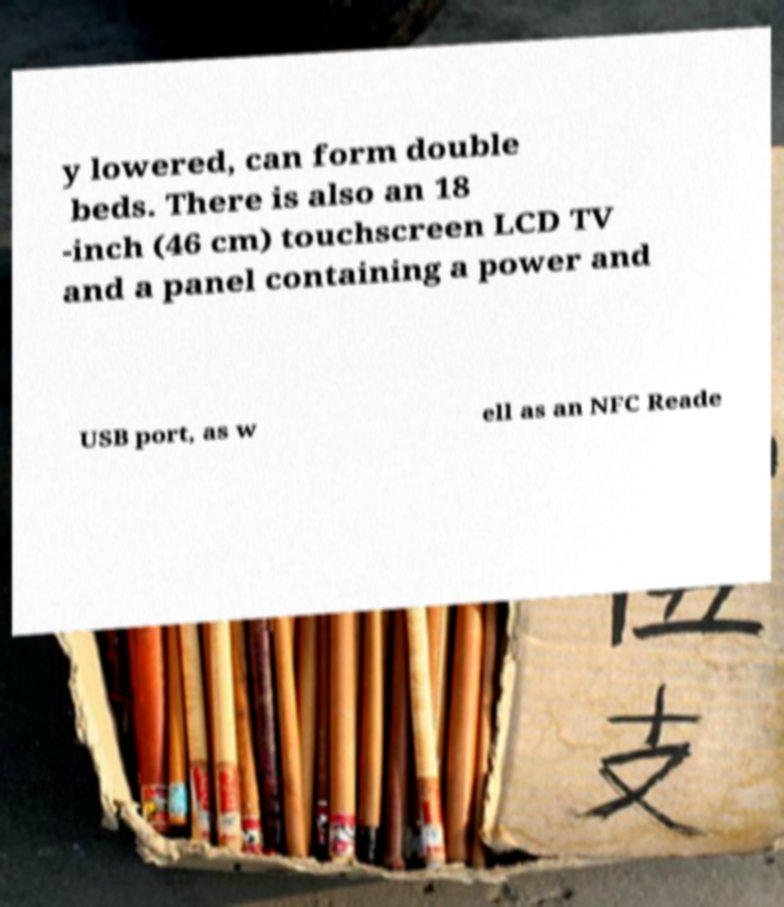There's text embedded in this image that I need extracted. Can you transcribe it verbatim? y lowered, can form double beds. There is also an 18 -inch (46 cm) touchscreen LCD TV and a panel containing a power and USB port, as w ell as an NFC Reade 